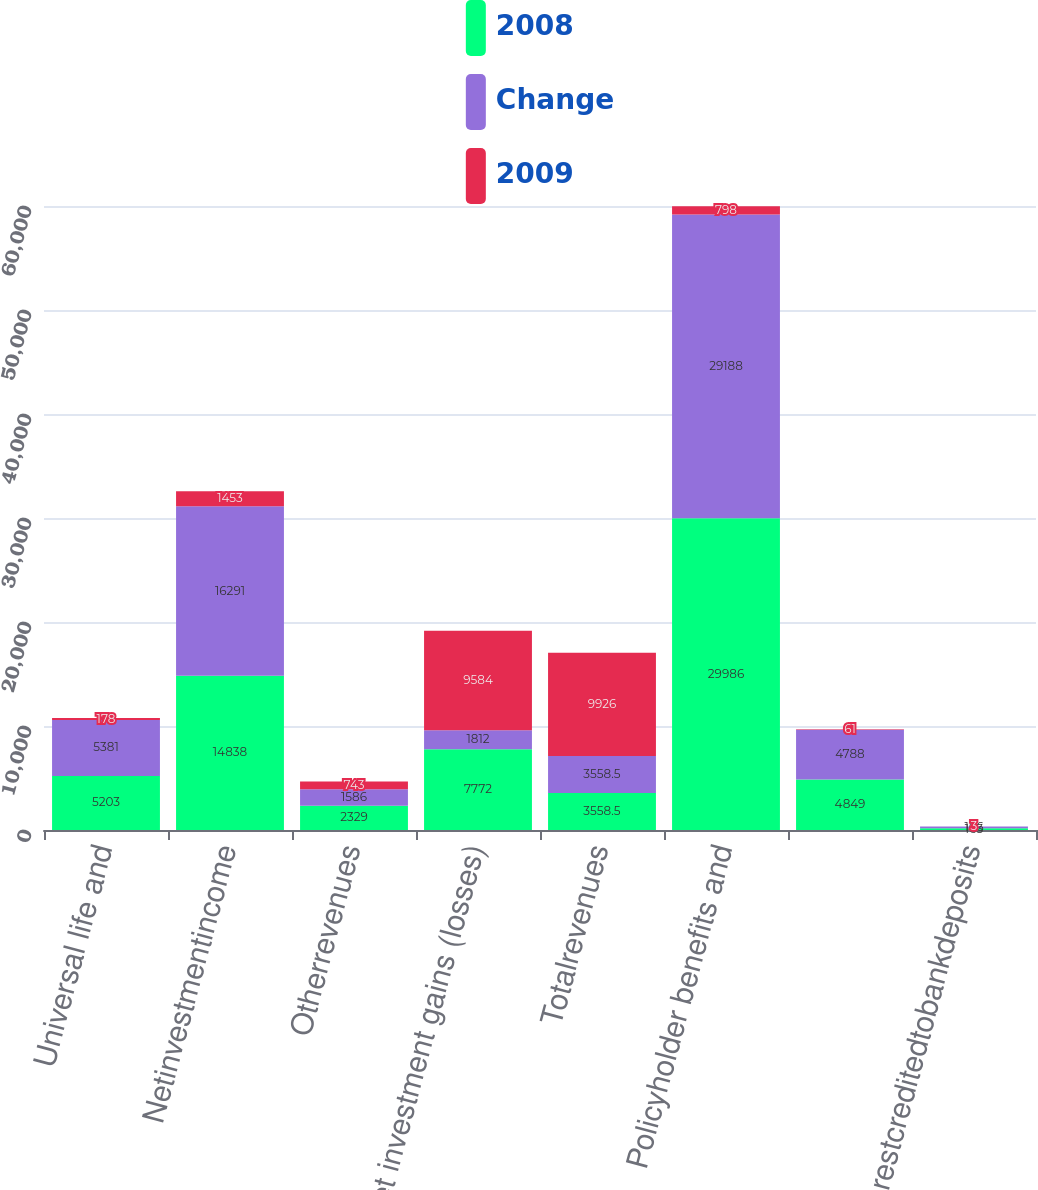Convert chart to OTSL. <chart><loc_0><loc_0><loc_500><loc_500><stacked_bar_chart><ecel><fcel>Universal life and<fcel>Netinvestmentincome<fcel>Otherrevenues<fcel>Net investment gains (losses)<fcel>Totalrevenues<fcel>Policyholder benefits and<fcel>Unnamed: 7<fcel>Interestcreditedtobankdeposits<nl><fcel>2008<fcel>5203<fcel>14838<fcel>2329<fcel>7772<fcel>3558.5<fcel>29986<fcel>4849<fcel>163<nl><fcel>Change<fcel>5381<fcel>16291<fcel>1586<fcel>1812<fcel>3558.5<fcel>29188<fcel>4788<fcel>166<nl><fcel>2009<fcel>178<fcel>1453<fcel>743<fcel>9584<fcel>9926<fcel>798<fcel>61<fcel>3<nl></chart> 